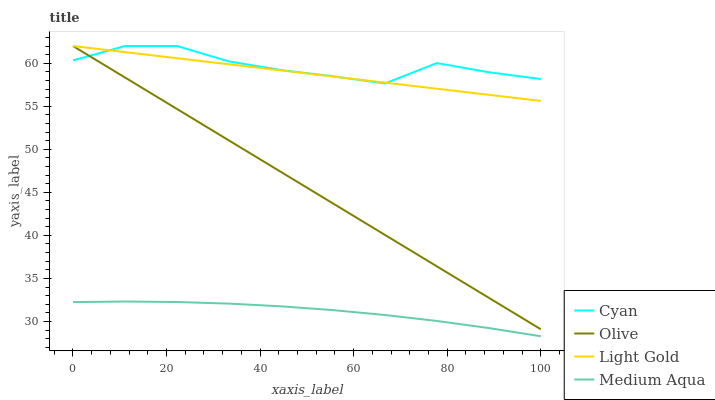Does Cyan have the minimum area under the curve?
Answer yes or no. No. Does Medium Aqua have the maximum area under the curve?
Answer yes or no. No. Is Medium Aqua the smoothest?
Answer yes or no. No. Is Medium Aqua the roughest?
Answer yes or no. No. Does Cyan have the lowest value?
Answer yes or no. No. Does Medium Aqua have the highest value?
Answer yes or no. No. Is Medium Aqua less than Light Gold?
Answer yes or no. Yes. Is Olive greater than Medium Aqua?
Answer yes or no. Yes. Does Medium Aqua intersect Light Gold?
Answer yes or no. No. 